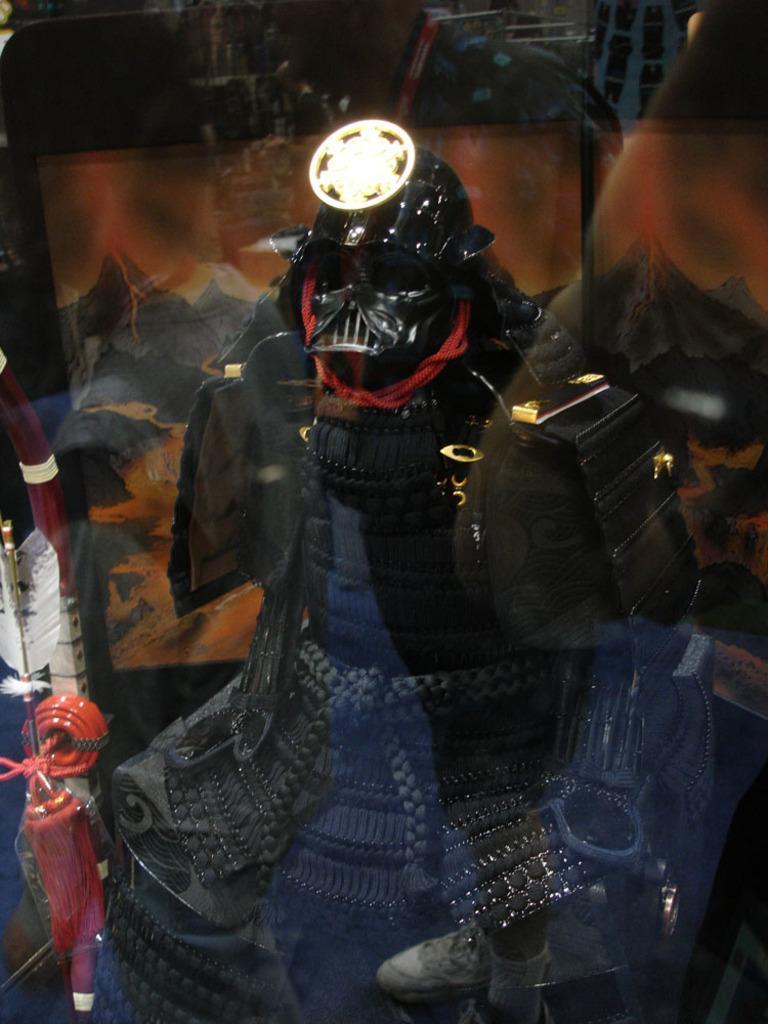How would you summarize this image in a sentence or two? In this image we can see a black color robotic toy is kept under a glass. 